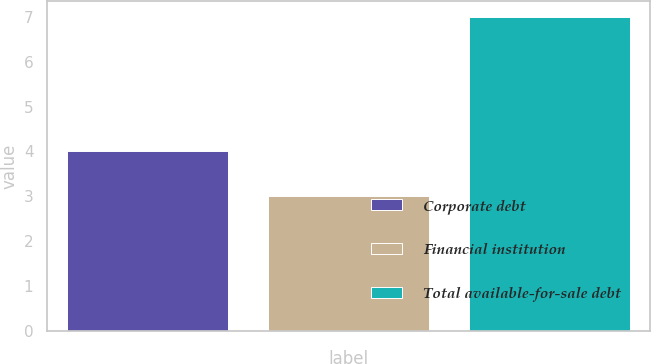Convert chart. <chart><loc_0><loc_0><loc_500><loc_500><bar_chart><fcel>Corporate debt<fcel>Financial institution<fcel>Total available-for-sale debt<nl><fcel>4<fcel>3<fcel>7<nl></chart> 